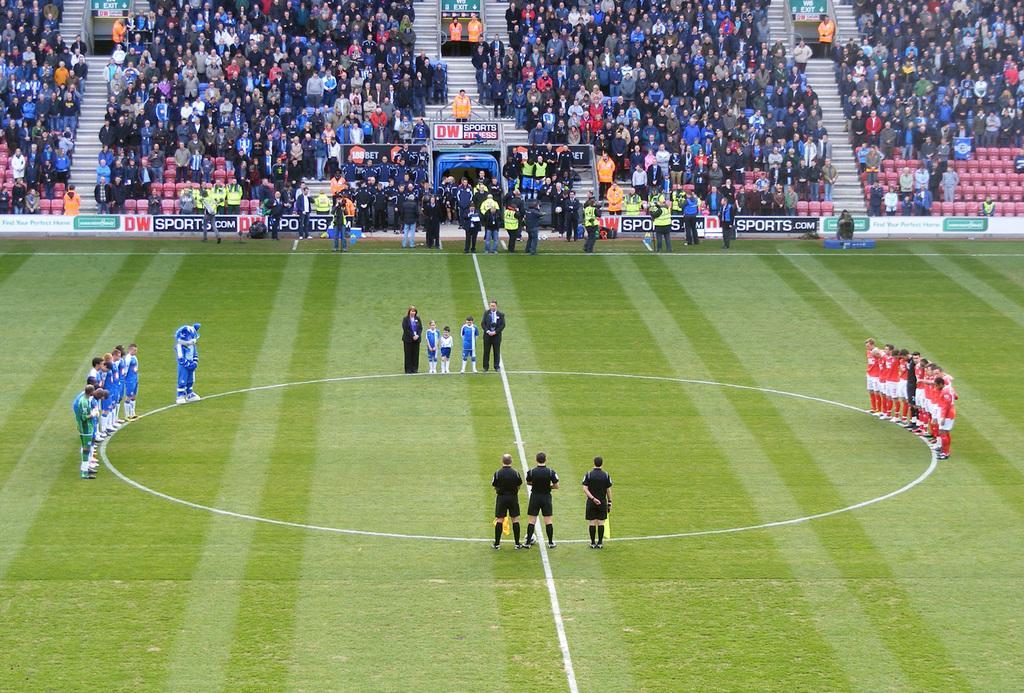Could you give a brief overview of what you see in this image? Here in this picture we can see a ground, in which on the either side we can see a group of men standing over there and in the middle of it we can see referees and some other people present over there and behind them we can see other number of people who came to watch the game, standing in the stands over there and we can see the ground is fully covered with grass over there. 